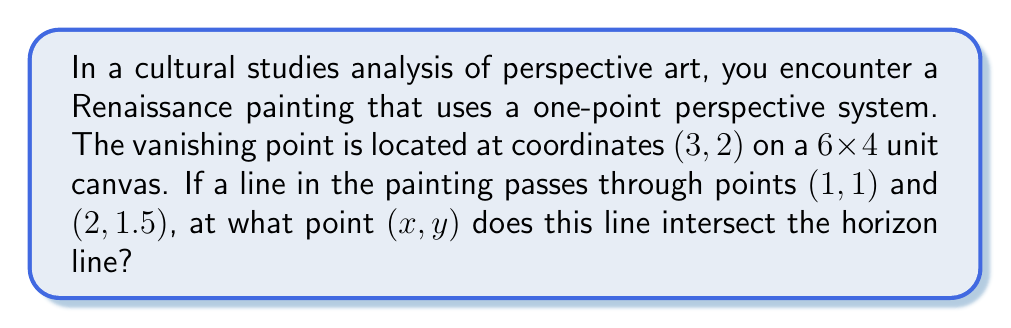Give your solution to this math problem. To solve this problem, we'll use concepts from projective geometry and linear algebra. Let's approach this step-by-step:

1) First, we need to determine the equation of the horizon line. In a one-point perspective system, the horizon line passes through the vanishing point and is horizontal. Therefore, its equation is:

   $y = 2$ (since the y-coordinate of the vanishing point is 2)

2) Next, we need to find the equation of the line passing through (1, 1) and (2, 1.5). We can use the point-slope form of a line:

   $y - y_1 = m(x - x_1)$

   where $m$ is the slope of the line.

3) Calculate the slope:
   
   $m = \frac{y_2 - y_1}{x_2 - x_1} = \frac{1.5 - 1}{2 - 1} = 0.5$

4) Now we can write the equation of this line:

   $y - 1 = 0.5(x - 1)$
   $y = 0.5x + 0.5$

5) To find the intersection point, we need to solve the system of equations:

   $y = 2$
   $y = 0.5x + 0.5$

6) Substitute the first equation into the second:

   $2 = 0.5x + 0.5$
   $1.5 = 0.5x$
   $x = 3$

7) Now that we have x, we can find y (although we already know it's 2):

   $y = 0.5(3) + 0.5 = 2$

Therefore, the line intersects the horizon at the point (3, 2), which is precisely the vanishing point.
Answer: (3, 2) 